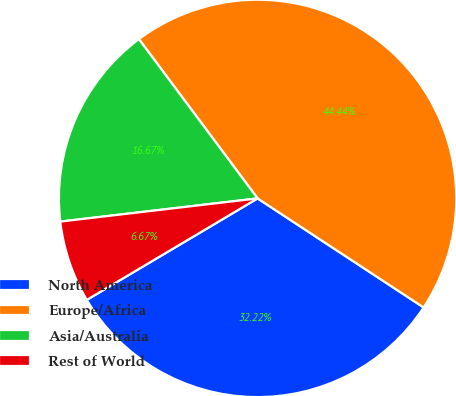Convert chart to OTSL. <chart><loc_0><loc_0><loc_500><loc_500><pie_chart><fcel>North America<fcel>Europe/Africa<fcel>Asia/Australia<fcel>Rest of World<nl><fcel>32.22%<fcel>44.44%<fcel>16.67%<fcel>6.67%<nl></chart> 